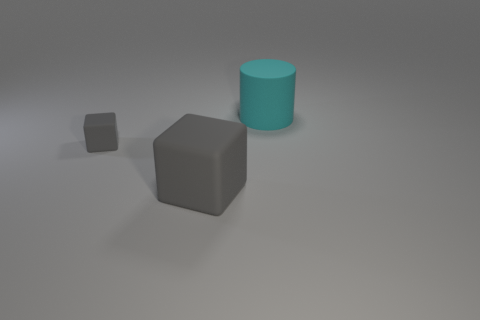Add 3 small rubber objects. How many objects exist? 6 Subtract all cylinders. How many objects are left? 2 Subtract 0 red balls. How many objects are left? 3 Subtract all green blocks. Subtract all red cylinders. How many blocks are left? 2 Subtract all big things. Subtract all large rubber cylinders. How many objects are left? 0 Add 2 tiny gray blocks. How many tiny gray blocks are left? 3 Add 1 metal things. How many metal things exist? 1 